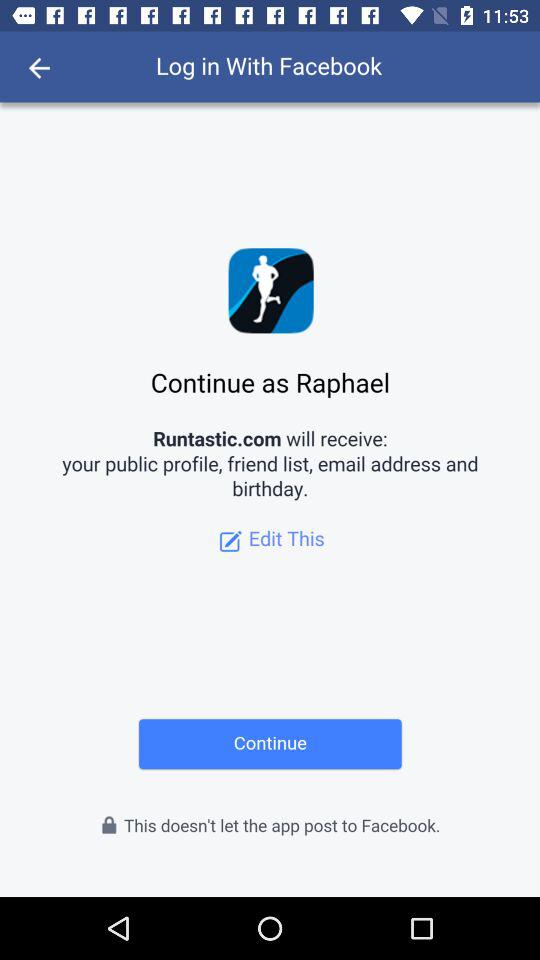What is the user name? The user name is "Raphael". 